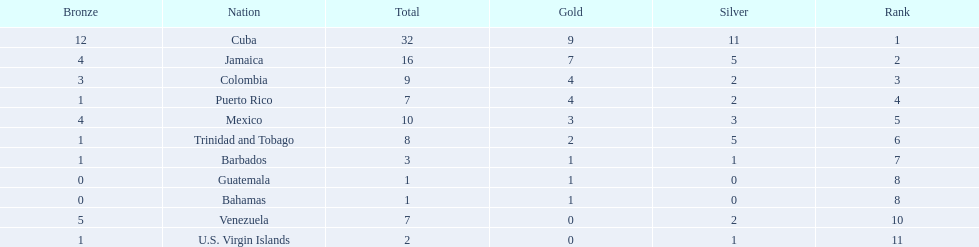What teams had four gold medals? Colombia, Puerto Rico. Of these two, which team only had one bronze medal? Puerto Rico. 